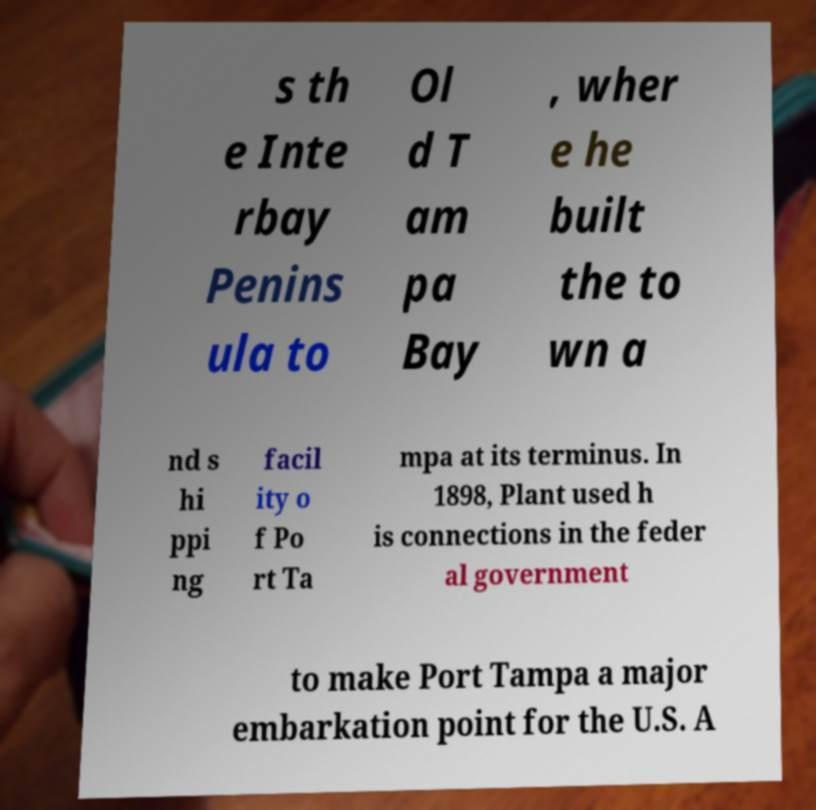There's text embedded in this image that I need extracted. Can you transcribe it verbatim? s th e Inte rbay Penins ula to Ol d T am pa Bay , wher e he built the to wn a nd s hi ppi ng facil ity o f Po rt Ta mpa at its terminus. In 1898, Plant used h is connections in the feder al government to make Port Tampa a major embarkation point for the U.S. A 